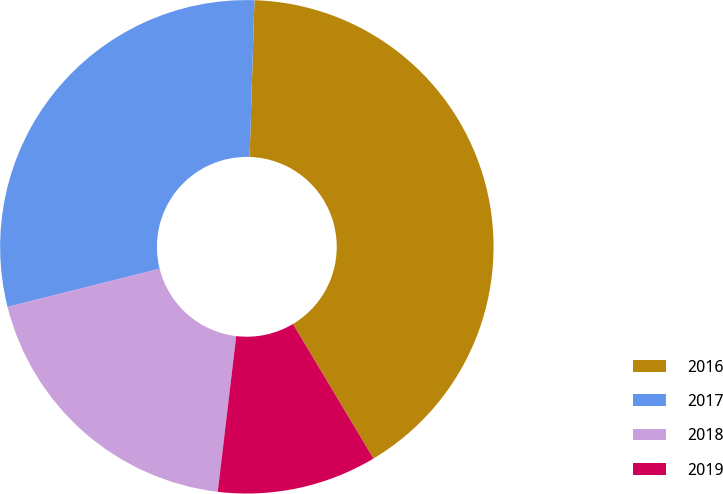Convert chart to OTSL. <chart><loc_0><loc_0><loc_500><loc_500><pie_chart><fcel>2016<fcel>2017<fcel>2018<fcel>2019<nl><fcel>40.93%<fcel>29.41%<fcel>19.2%<fcel>10.46%<nl></chart> 